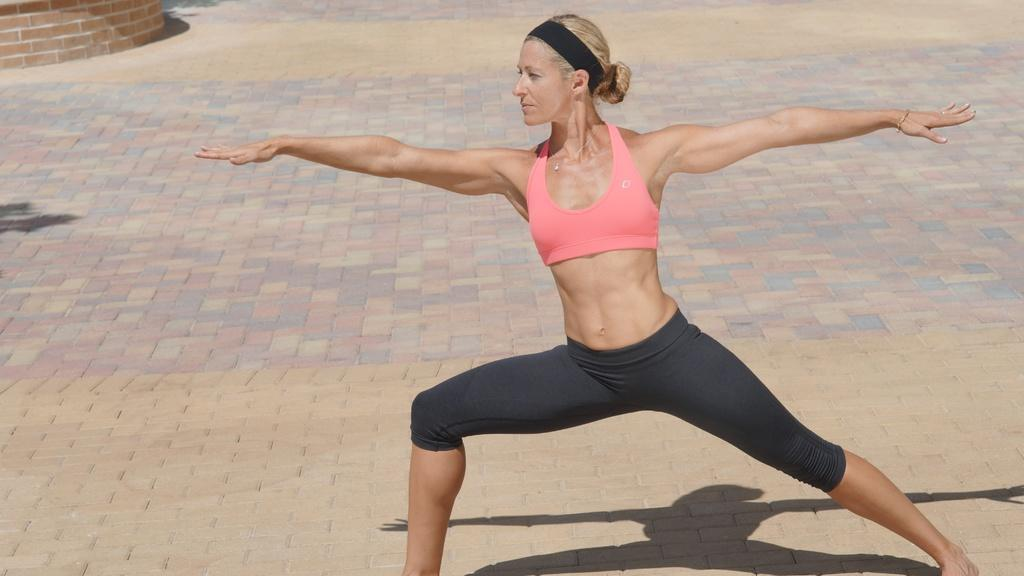Who is the main subject in the image? There is a woman in the picture. What is the woman doing in the image? The woman is standing and stretching her body. Can you describe the background of the image? There is a brick wall in the left top corner of the image. What verse is the woman reciting in the image? There is no indication in the image that the woman is reciting a verse, so it cannot be determined from the picture. 